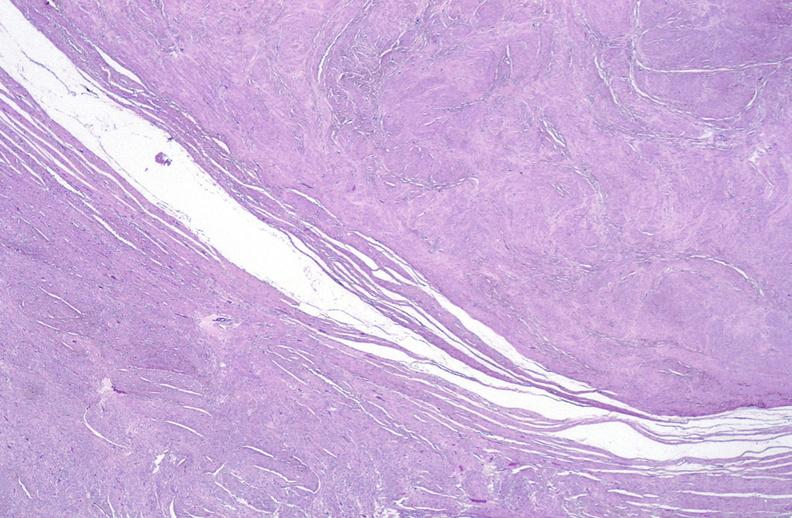s female reproductive present?
Answer the question using a single word or phrase. Yes 